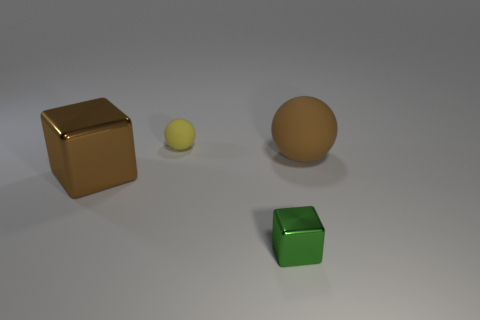Add 2 small green shiny objects. How many objects exist? 6 Add 2 matte spheres. How many matte spheres are left? 4 Add 2 brown blocks. How many brown blocks exist? 3 Subtract 0 cyan balls. How many objects are left? 4 Subtract all large yellow shiny cubes. Subtract all large brown matte balls. How many objects are left? 3 